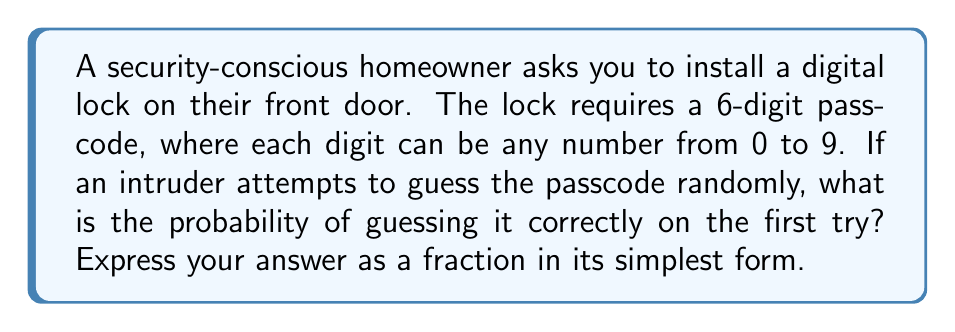Can you answer this question? Let's approach this step-by-step:

1) First, we need to determine the total number of possible 6-digit passcodes:
   - Each digit can be any number from 0 to 9, so there are 10 choices for each digit.
   - We have 6 digits in total.
   - Using the multiplication principle, the total number of possible passcodes is:
     $$ 10 \times 10 \times 10 \times 10 \times 10 \times 10 = 10^6 = 1,000,000 $$

2) Now, out of these 1,000,000 possible passcodes, only one is correct.

3) The probability of guessing the correct passcode is:
   $$ P(\text{correct guess}) = \frac{\text{number of favorable outcomes}}{\text{total number of possible outcomes}} = \frac{1}{1,000,000} $$

4) This fraction is already in its simplest form, as 1 and 1,000,000 have no common factors other than 1.

Therefore, the probability of guessing the passcode correctly on the first try is $\frac{1}{1,000,000}$.
Answer: $\frac{1}{1,000,000}$ 